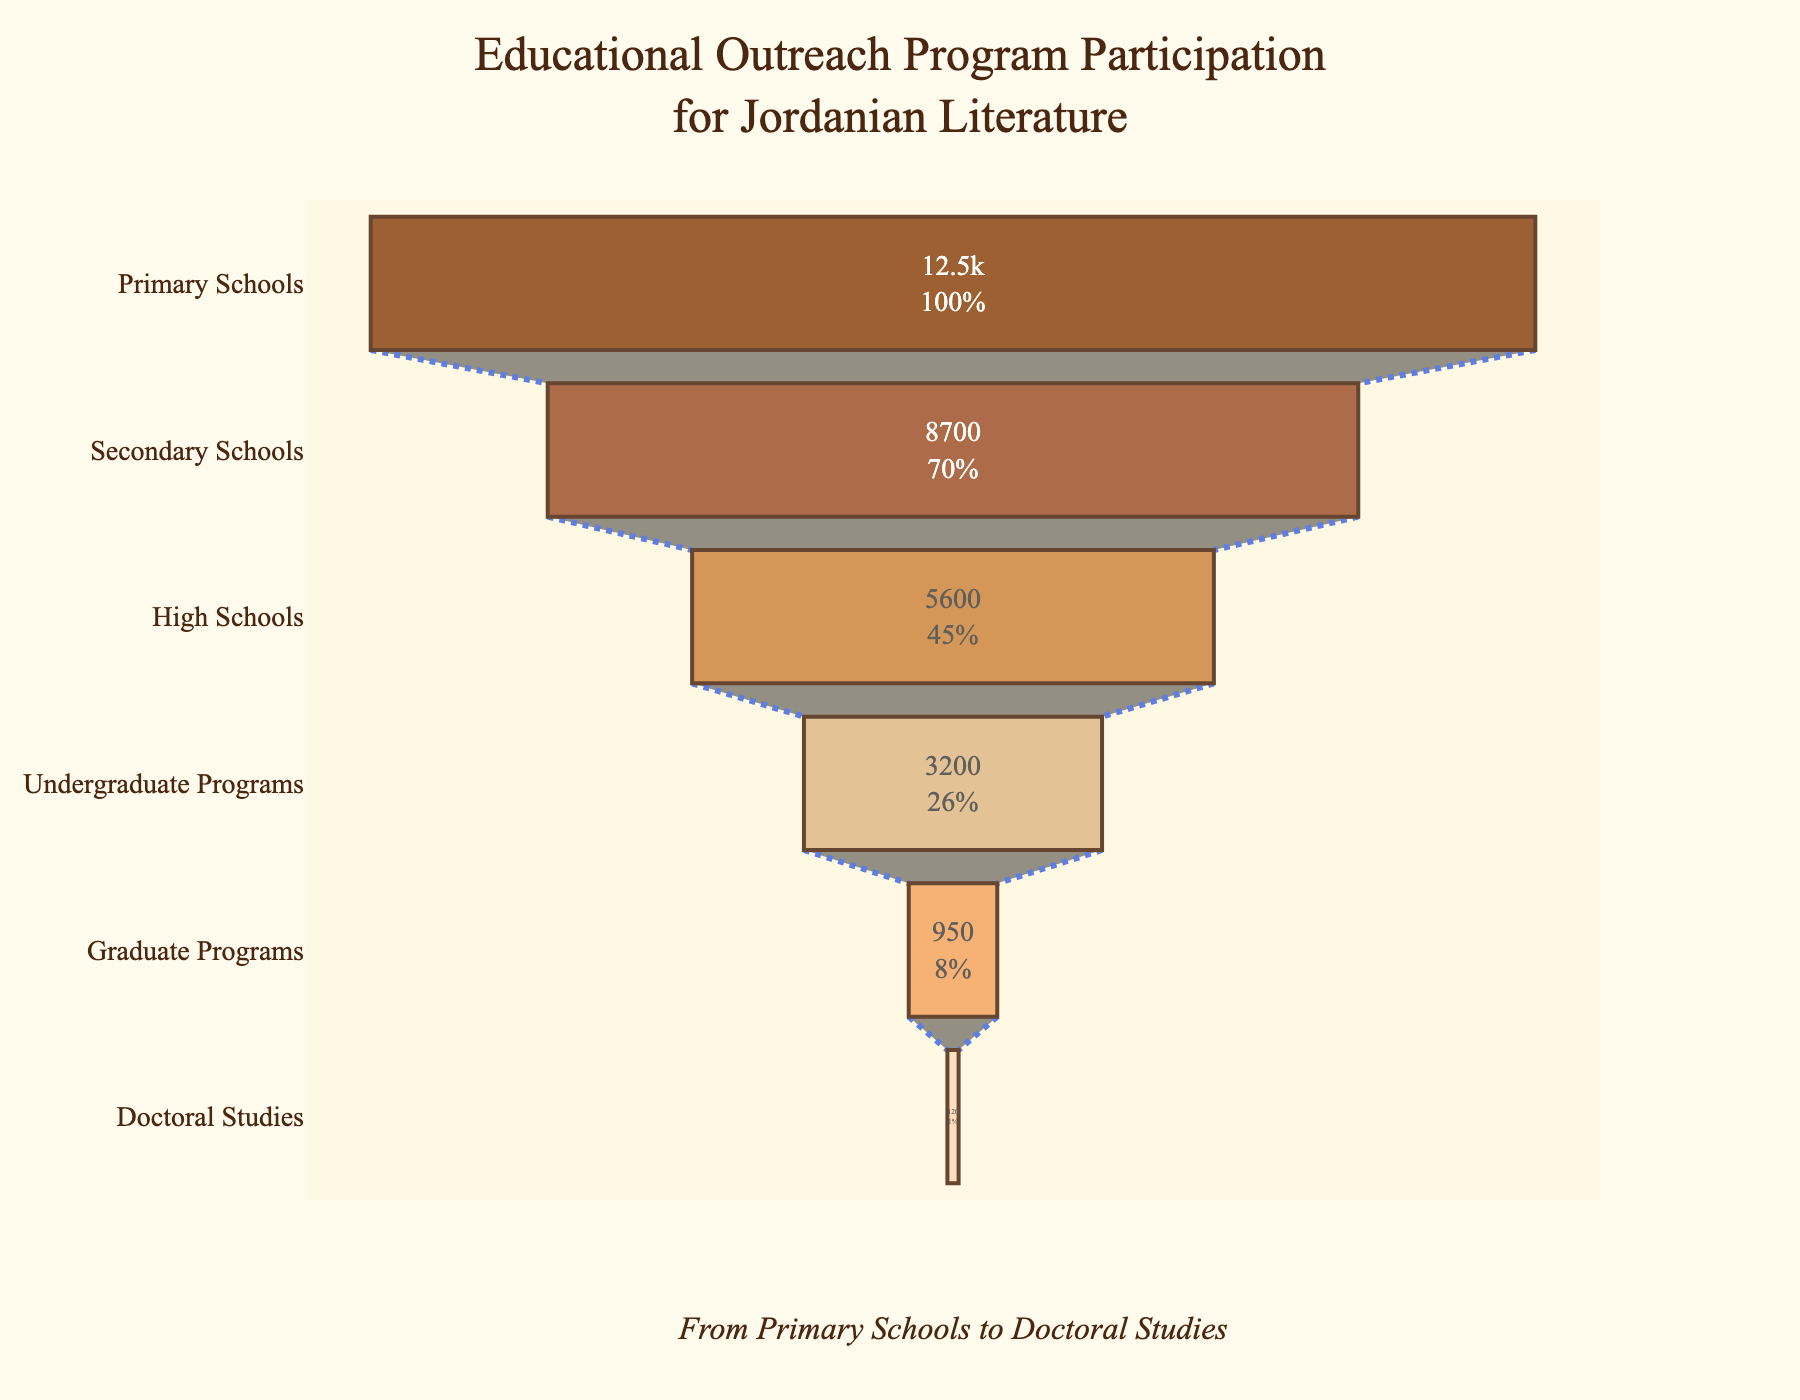How many participants are in Undergraduate Programs? The chart lists the number of participants at each educational stage. Find "Undergraduate Programs" and read the participant count.
Answer: 3200 What is the percentage drop from Primary Schools to High Schools? To find the percentage drop, first calculate the difference: 12500 - 5600 = 6900. Then, divide the difference by the initial value (Primary Schools): 6900 / 12500 ≈ 0.552. Finally, multiply by 100 to get the percentage: 0.552 × 100 ≈ 55.2%
Answer: 55.2% Which stage has the lowest participation? Look for the smallest value among the listed participant counts. "Doctoral Studies" has the smallest value, 120.
Answer: Doctoral Studies How many more participants are in Primary Schools compared to Graduate Programs? Subtract the number of participants in Graduate Programs from those in Primary Schools: 12500 - 950 = 11550
Answer: 11550 What is the title of the chart? The title is often positioned at the top of the chart. Here, the title is "Educational Outreach Program Participation for Jordanian Literature."
Answer: Educational Outreach Program Participation for Jordanian Literature Are there more participants in Secondary Schools or High Schools? Compare the participant counts for these stages. Secondary Schools have 8700 participants, while High Schools have 5600. Secondary Schools have more.
Answer: Secondary Schools What is the total number of participants from Undergraduate Programs to Doctoral Studies? Sum the participant numbers for these stages: 3200 + 950 + 120 = 4270
Answer: 4270 Which stage shows the most significant decrease in participation compared to its previous stage? Calculate the differences between consecutive stages: 
- Primary to Secondary: 12500 - 8700 = 3800
- Secondary to High: 8700 - 5600 = 3100
- High to Undergrad: 5600 - 3200 = 2400
- Undergrad to Grad: 3200 - 950 = 2250
- Grad to Doctoral: 950 - 120 = 830
The largest decrease is between Primary and Secondary Schools.
Answer: Primary Schools to Secondary Schools How is the data visualized in the chart? The chart uses a funnel diagram layout, where each stage is represented as a horizontal segment. The width of each segment corresponds to the number of participants.
Answer: Funnel Chart 